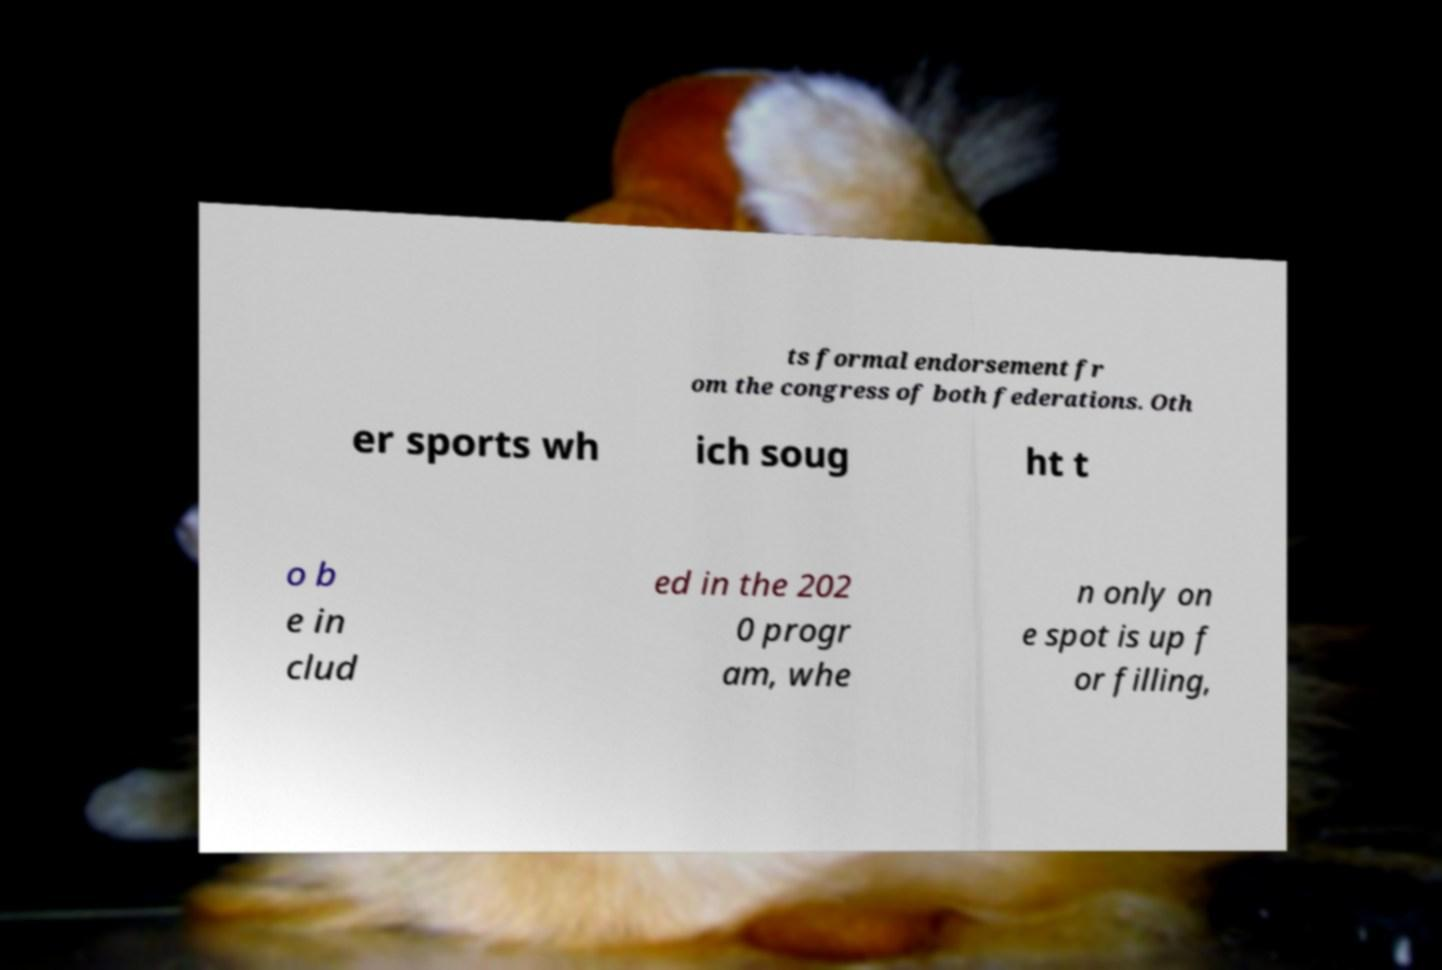Could you extract and type out the text from this image? ts formal endorsement fr om the congress of both federations. Oth er sports wh ich soug ht t o b e in clud ed in the 202 0 progr am, whe n only on e spot is up f or filling, 